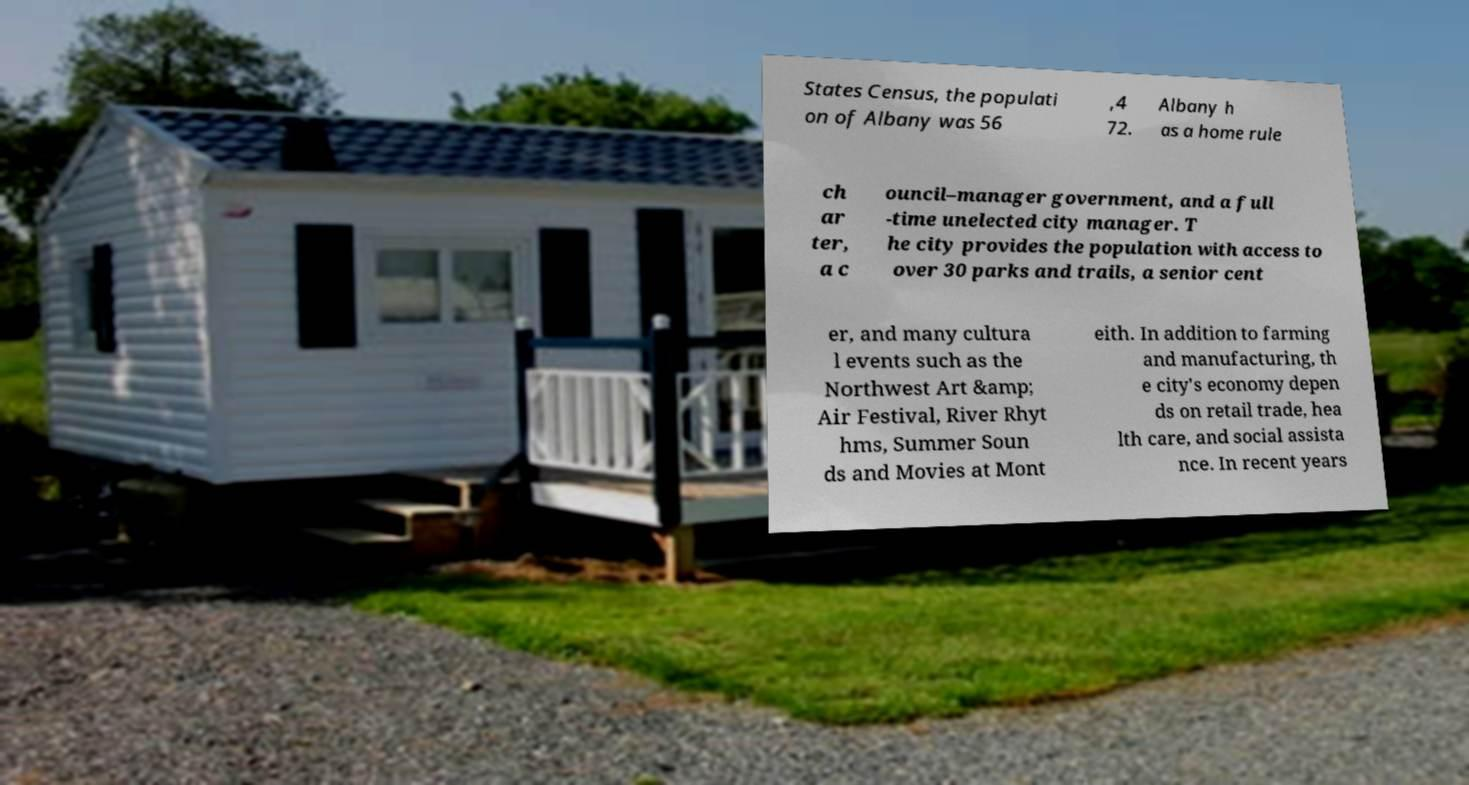Could you extract and type out the text from this image? States Census, the populati on of Albany was 56 ,4 72. Albany h as a home rule ch ar ter, a c ouncil–manager government, and a full -time unelected city manager. T he city provides the population with access to over 30 parks and trails, a senior cent er, and many cultura l events such as the Northwest Art &amp; Air Festival, River Rhyt hms, Summer Soun ds and Movies at Mont eith. In addition to farming and manufacturing, th e city's economy depen ds on retail trade, hea lth care, and social assista nce. In recent years 